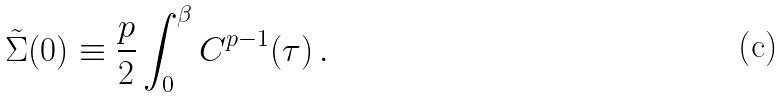<formula> <loc_0><loc_0><loc_500><loc_500>\tilde { \Sigma } ( 0 ) \equiv \frac { p } { 2 } \int _ { 0 } ^ { \beta } C ^ { p - 1 } ( \tau ) \, .</formula> 